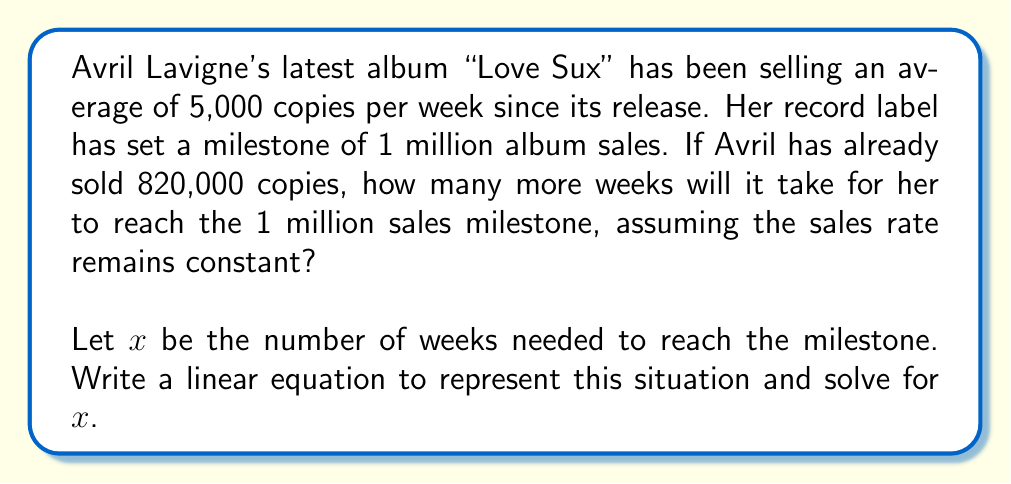Show me your answer to this math problem. Let's approach this step-by-step:

1) First, let's identify the important information:
   - Current sales: 820,000 copies
   - Sales goal (milestone): 1,000,000 copies
   - Weekly sales rate: 5,000 copies/week

2) We need to find how many more copies need to be sold:
   $1,000,000 - 820,000 = 180,000$ copies

3) Now, we can set up our linear equation:
   Let $x$ be the number of weeks needed.
   Weekly sales rate × Number of weeks = Additional copies needed
   $$5,000x = 180,000$$

4) To solve for $x$, we divide both sides by 5,000:
   $$x = \frac{180,000}{5,000} = 36$$

Therefore, it will take 36 weeks to reach the sales milestone.
Answer: $36$ weeks 